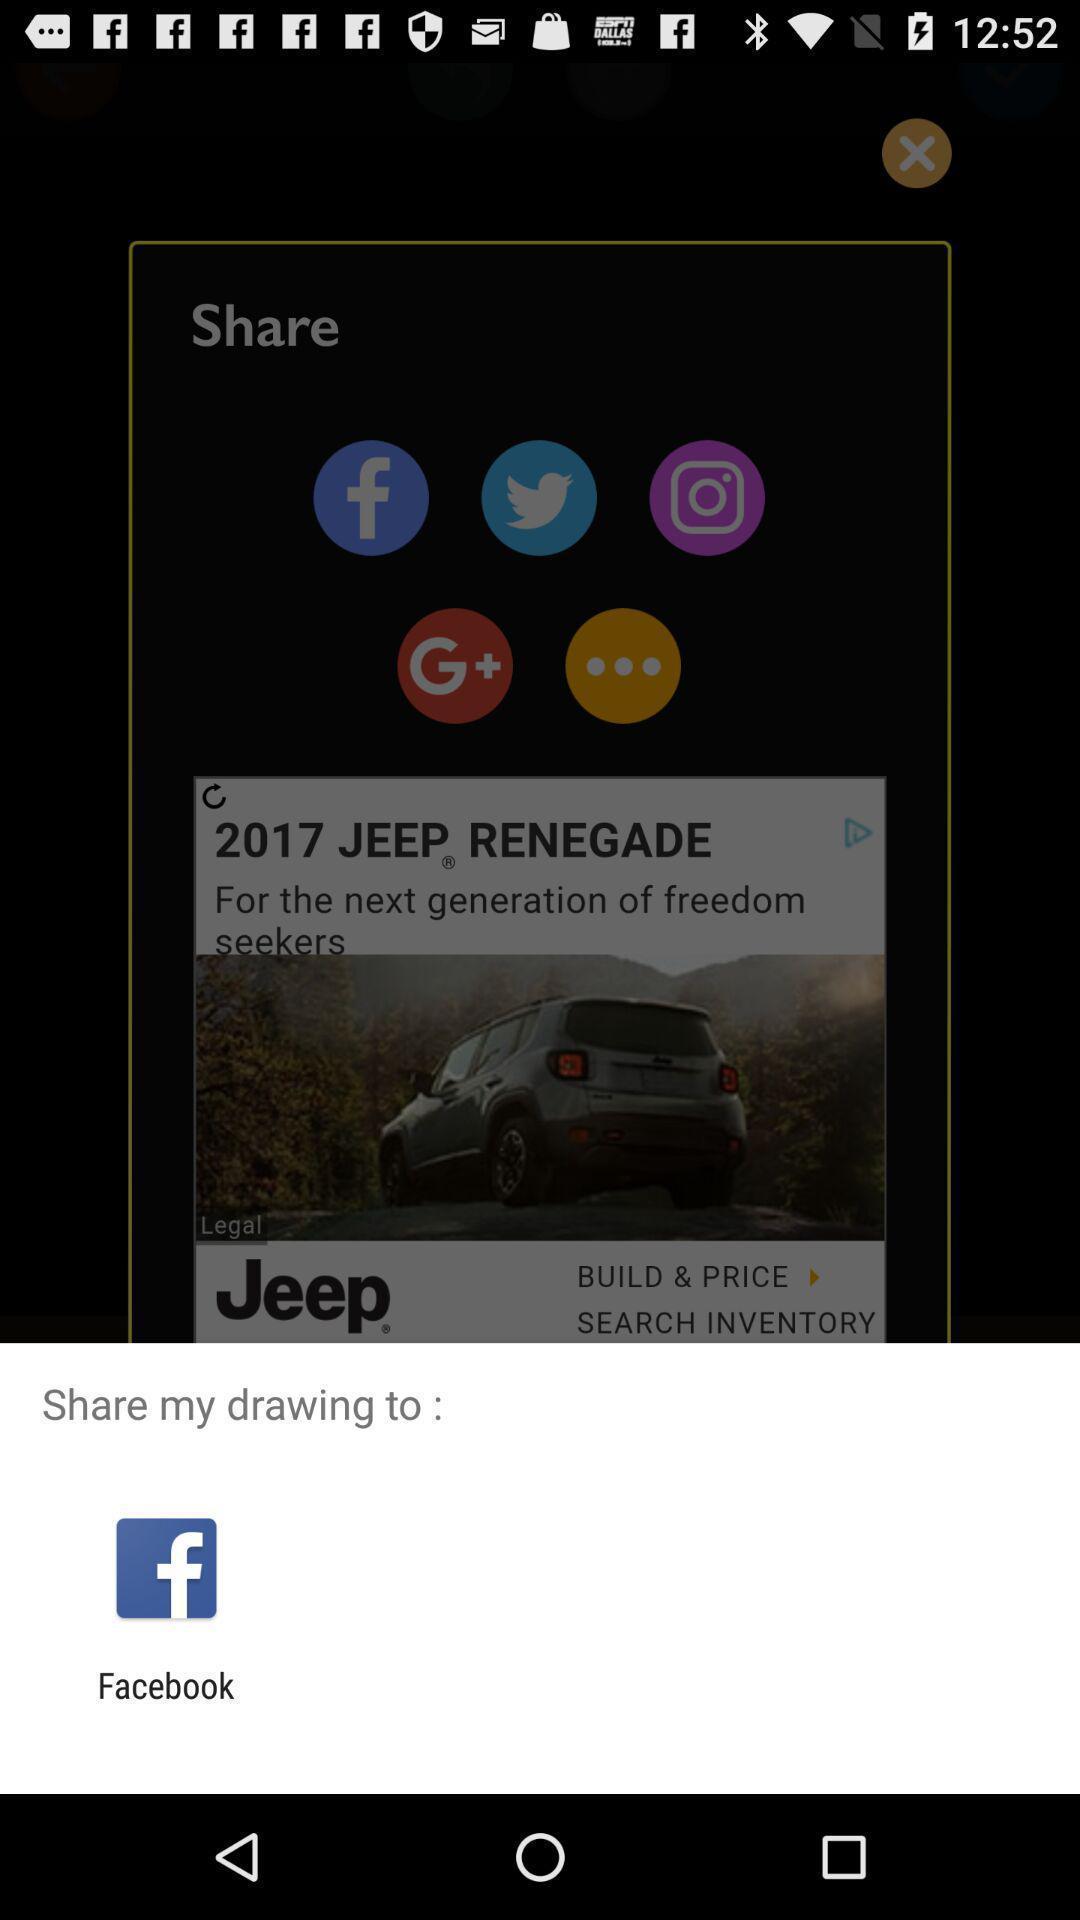Summarize the information in this screenshot. Sharing options pop up on a drawing app. 